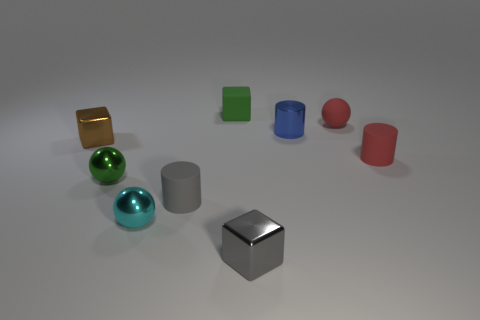Add 1 small gray rubber cylinders. How many objects exist? 10 Subtract all balls. How many objects are left? 6 Subtract 0 purple spheres. How many objects are left? 9 Subtract all tiny blue shiny objects. Subtract all small gray rubber cylinders. How many objects are left? 7 Add 3 tiny matte balls. How many tiny matte balls are left? 4 Add 4 gray blocks. How many gray blocks exist? 5 